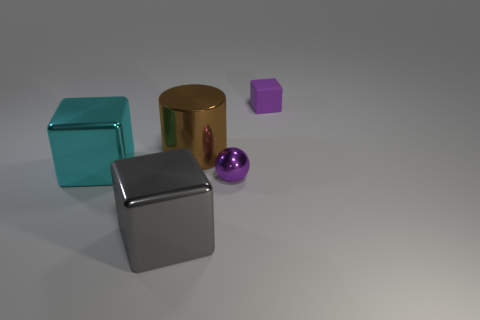Add 4 small yellow objects. How many objects exist? 9 Subtract all spheres. How many objects are left? 4 Subtract all yellow rubber blocks. Subtract all tiny purple objects. How many objects are left? 3 Add 3 cyan metallic cubes. How many cyan metallic cubes are left? 4 Add 4 small purple matte objects. How many small purple matte objects exist? 5 Subtract 0 yellow cylinders. How many objects are left? 5 